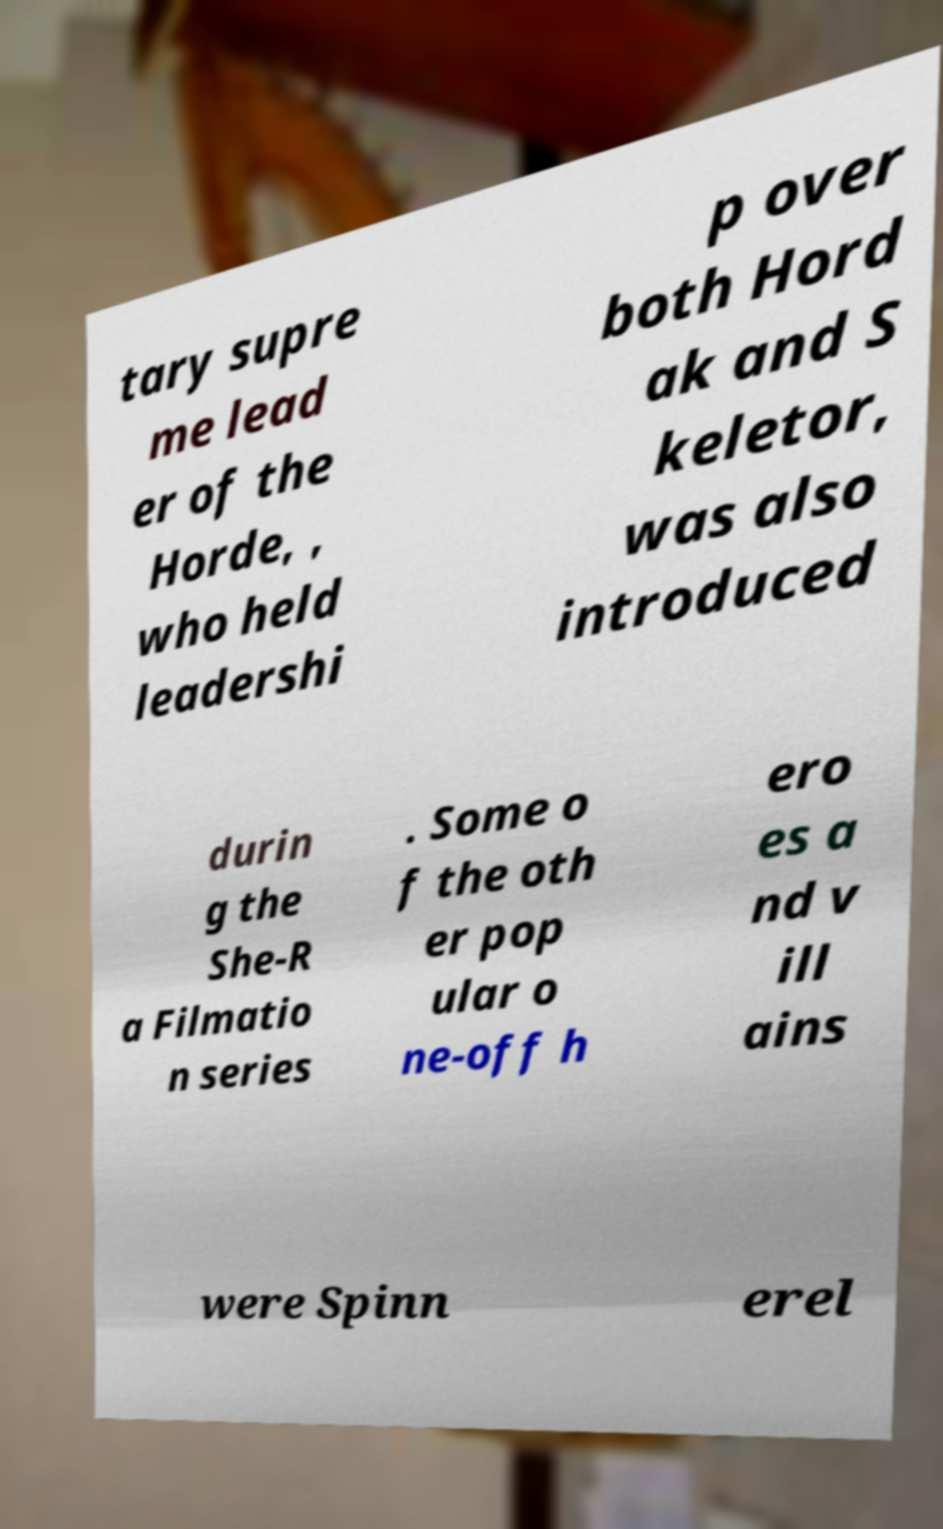Please read and relay the text visible in this image. What does it say? tary supre me lead er of the Horde, , who held leadershi p over both Hord ak and S keletor, was also introduced durin g the She-R a Filmatio n series . Some o f the oth er pop ular o ne-off h ero es a nd v ill ains were Spinn erel 